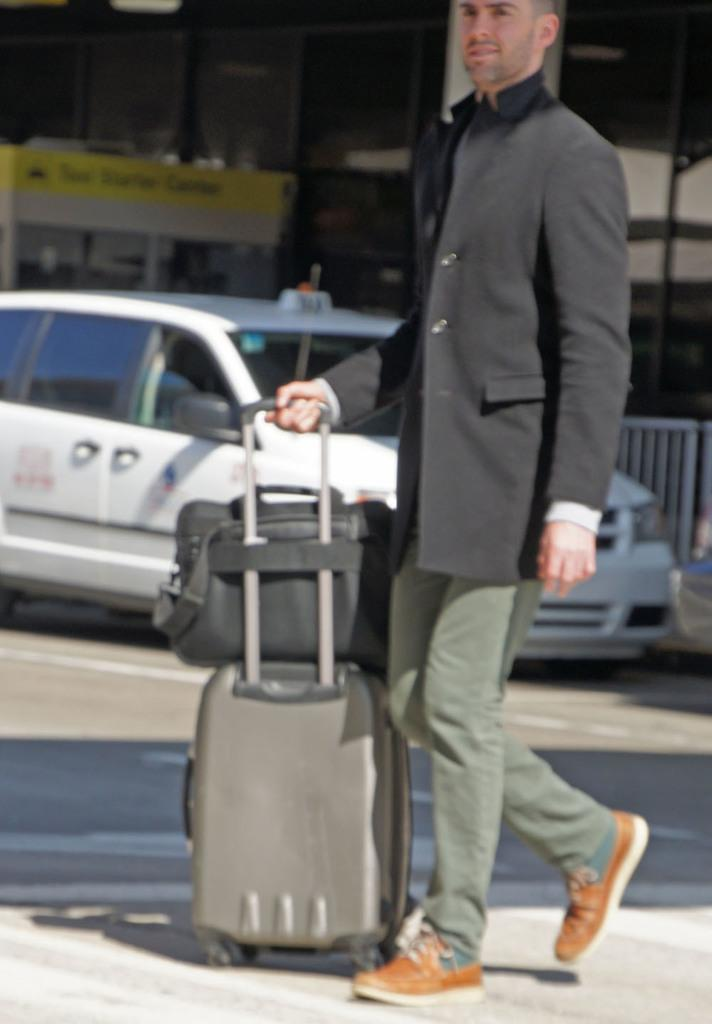What is the main subject of the image? There is a person in the image. What is the person doing in the image? The person is standing. What items is the person holding in the image? The person is holding a travel bag and a suitcase. What can be seen in the background of the image? There is a car parked on the road in the image. What type of nail is being used to apply wax to the person's face in the image? There is no nail or wax present in the image; the person is holding a travel bag and a suitcase. 